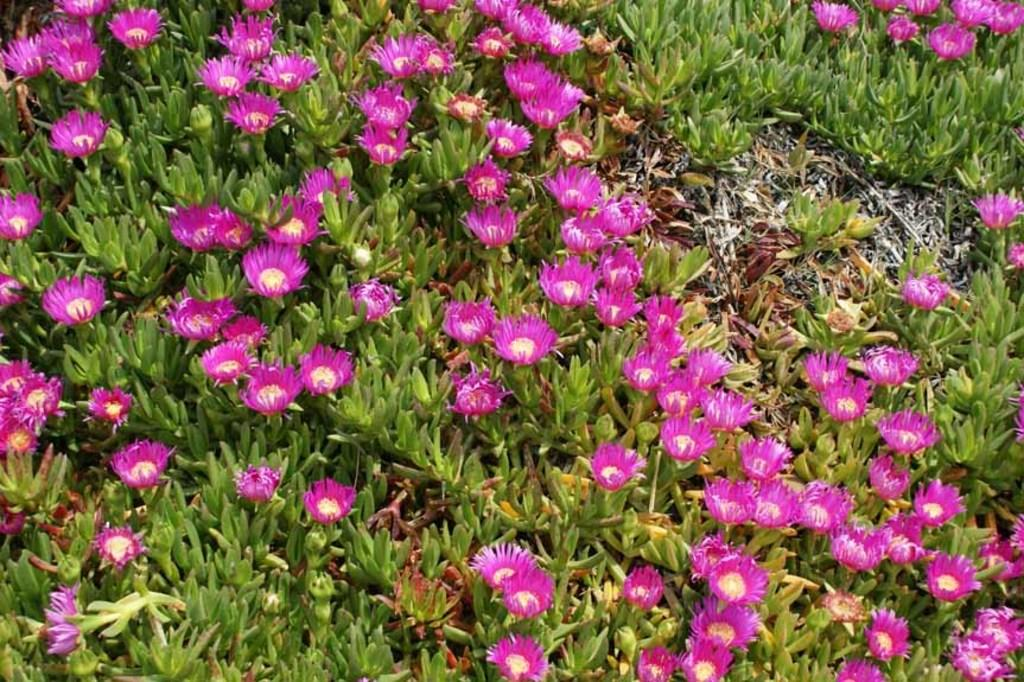What color are the flowers in the image? The flowers in the image are pink. What color are the plants in the image? The plants in the image are green. What time does the clock in the image show? There is no clock present in the image. What does the dad in the image say about the flowers? There is no dad or any dialogue present in the image. 